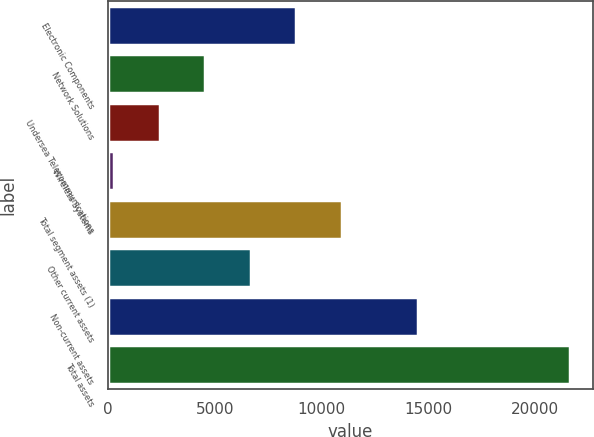Convert chart to OTSL. <chart><loc_0><loc_0><loc_500><loc_500><bar_chart><fcel>Electronic Components<fcel>Network Solutions<fcel>Undersea Telecommunications<fcel>Wireless Systems<fcel>Total segment assets (1)<fcel>Other current assets<fcel>Non-current assets<fcel>Total assets<nl><fcel>8809.2<fcel>4545.6<fcel>2413.8<fcel>282<fcel>10941<fcel>6677.4<fcel>14505<fcel>21600<nl></chart> 